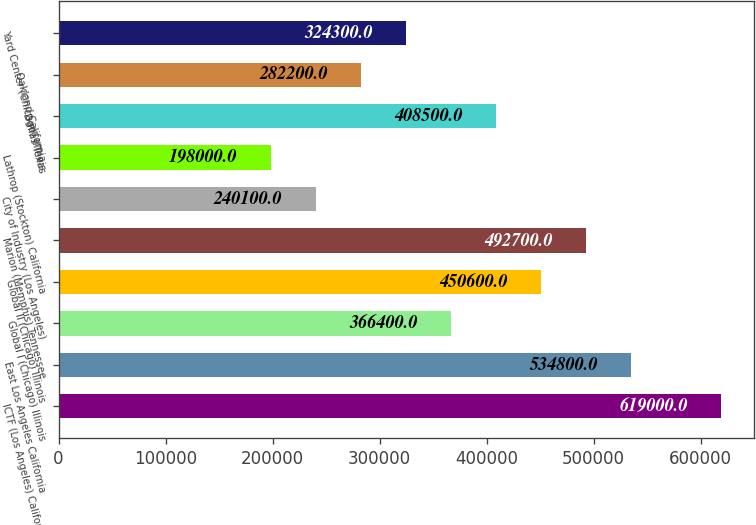Convert chart. <chart><loc_0><loc_0><loc_500><loc_500><bar_chart><fcel>ICTF (Los Angeles) California<fcel>East Los Angeles California<fcel>Global I (Chicago) Illinois<fcel>Global II (Chicago) Illinois<fcel>Marion (Memphis) Tennessee<fcel>City of Industry (Los Angeles)<fcel>Lathrop (Stockton) California<fcel>Dallas Texas<fcel>Oakland California<fcel>Yard Center (Chicago) Illinois<nl><fcel>619000<fcel>534800<fcel>366400<fcel>450600<fcel>492700<fcel>240100<fcel>198000<fcel>408500<fcel>282200<fcel>324300<nl></chart> 